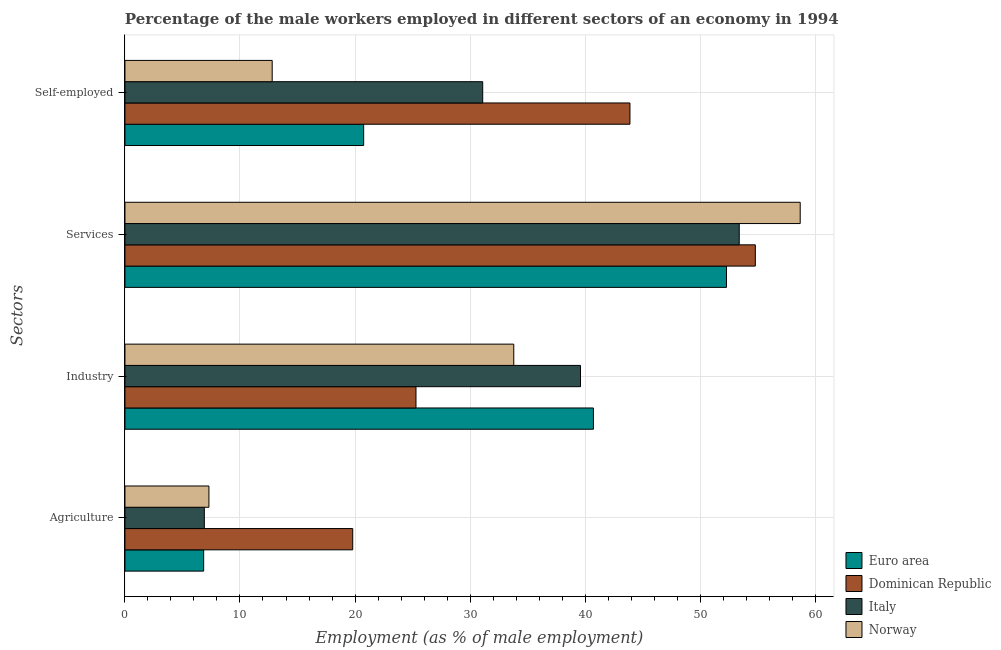How many different coloured bars are there?
Offer a very short reply. 4. How many groups of bars are there?
Offer a very short reply. 4. How many bars are there on the 4th tick from the bottom?
Ensure brevity in your answer.  4. What is the label of the 2nd group of bars from the top?
Offer a very short reply. Services. What is the percentage of male workers in agriculture in Dominican Republic?
Give a very brief answer. 19.8. Across all countries, what is the maximum percentage of male workers in services?
Ensure brevity in your answer.  58.7. Across all countries, what is the minimum percentage of self employed male workers?
Make the answer very short. 12.8. In which country was the percentage of male workers in agriculture maximum?
Keep it short and to the point. Dominican Republic. What is the total percentage of self employed male workers in the graph?
Provide a succinct answer. 108.55. What is the difference between the percentage of male workers in services in Italy and that in Dominican Republic?
Make the answer very short. -1.4. What is the difference between the percentage of self employed male workers in Norway and the percentage of male workers in industry in Italy?
Provide a short and direct response. -26.8. What is the average percentage of self employed male workers per country?
Offer a terse response. 27.14. What is the difference between the percentage of self employed male workers and percentage of male workers in services in Norway?
Offer a terse response. -45.9. What is the ratio of the percentage of male workers in agriculture in Norway to that in Italy?
Ensure brevity in your answer.  1.06. What is the difference between the highest and the second highest percentage of male workers in agriculture?
Ensure brevity in your answer.  12.5. What is the difference between the highest and the lowest percentage of male workers in industry?
Keep it short and to the point. 15.42. What does the 2nd bar from the bottom in Self-employed represents?
Offer a very short reply. Dominican Republic. Is it the case that in every country, the sum of the percentage of male workers in agriculture and percentage of male workers in industry is greater than the percentage of male workers in services?
Offer a very short reply. No. How many countries are there in the graph?
Offer a very short reply. 4. What is the difference between two consecutive major ticks on the X-axis?
Offer a very short reply. 10. Does the graph contain grids?
Ensure brevity in your answer.  Yes. What is the title of the graph?
Keep it short and to the point. Percentage of the male workers employed in different sectors of an economy in 1994. Does "Cambodia" appear as one of the legend labels in the graph?
Provide a short and direct response. No. What is the label or title of the X-axis?
Keep it short and to the point. Employment (as % of male employment). What is the label or title of the Y-axis?
Your response must be concise. Sectors. What is the Employment (as % of male employment) in Euro area in Agriculture?
Your response must be concise. 6.84. What is the Employment (as % of male employment) of Dominican Republic in Agriculture?
Make the answer very short. 19.8. What is the Employment (as % of male employment) in Italy in Agriculture?
Your response must be concise. 6.9. What is the Employment (as % of male employment) in Norway in Agriculture?
Give a very brief answer. 7.3. What is the Employment (as % of male employment) of Euro area in Industry?
Give a very brief answer. 40.72. What is the Employment (as % of male employment) in Dominican Republic in Industry?
Provide a succinct answer. 25.3. What is the Employment (as % of male employment) of Italy in Industry?
Give a very brief answer. 39.6. What is the Employment (as % of male employment) in Norway in Industry?
Your answer should be very brief. 33.8. What is the Employment (as % of male employment) in Euro area in Services?
Keep it short and to the point. 52.29. What is the Employment (as % of male employment) in Dominican Republic in Services?
Your answer should be very brief. 54.8. What is the Employment (as % of male employment) of Italy in Services?
Your answer should be very brief. 53.4. What is the Employment (as % of male employment) of Norway in Services?
Keep it short and to the point. 58.7. What is the Employment (as % of male employment) in Euro area in Self-employed?
Offer a terse response. 20.75. What is the Employment (as % of male employment) of Dominican Republic in Self-employed?
Keep it short and to the point. 43.9. What is the Employment (as % of male employment) of Italy in Self-employed?
Offer a very short reply. 31.1. What is the Employment (as % of male employment) of Norway in Self-employed?
Provide a succinct answer. 12.8. Across all Sectors, what is the maximum Employment (as % of male employment) of Euro area?
Offer a very short reply. 52.29. Across all Sectors, what is the maximum Employment (as % of male employment) in Dominican Republic?
Offer a terse response. 54.8. Across all Sectors, what is the maximum Employment (as % of male employment) of Italy?
Offer a terse response. 53.4. Across all Sectors, what is the maximum Employment (as % of male employment) in Norway?
Your response must be concise. 58.7. Across all Sectors, what is the minimum Employment (as % of male employment) of Euro area?
Make the answer very short. 6.84. Across all Sectors, what is the minimum Employment (as % of male employment) of Dominican Republic?
Your response must be concise. 19.8. Across all Sectors, what is the minimum Employment (as % of male employment) in Italy?
Ensure brevity in your answer.  6.9. Across all Sectors, what is the minimum Employment (as % of male employment) of Norway?
Make the answer very short. 7.3. What is the total Employment (as % of male employment) in Euro area in the graph?
Offer a terse response. 120.61. What is the total Employment (as % of male employment) of Dominican Republic in the graph?
Your response must be concise. 143.8. What is the total Employment (as % of male employment) in Italy in the graph?
Your response must be concise. 131. What is the total Employment (as % of male employment) in Norway in the graph?
Your answer should be compact. 112.6. What is the difference between the Employment (as % of male employment) of Euro area in Agriculture and that in Industry?
Offer a terse response. -33.88. What is the difference between the Employment (as % of male employment) of Italy in Agriculture and that in Industry?
Keep it short and to the point. -32.7. What is the difference between the Employment (as % of male employment) of Norway in Agriculture and that in Industry?
Offer a terse response. -26.5. What is the difference between the Employment (as % of male employment) of Euro area in Agriculture and that in Services?
Provide a succinct answer. -45.45. What is the difference between the Employment (as % of male employment) in Dominican Republic in Agriculture and that in Services?
Provide a short and direct response. -35. What is the difference between the Employment (as % of male employment) in Italy in Agriculture and that in Services?
Your answer should be compact. -46.5. What is the difference between the Employment (as % of male employment) of Norway in Agriculture and that in Services?
Offer a terse response. -51.4. What is the difference between the Employment (as % of male employment) of Euro area in Agriculture and that in Self-employed?
Make the answer very short. -13.91. What is the difference between the Employment (as % of male employment) in Dominican Republic in Agriculture and that in Self-employed?
Keep it short and to the point. -24.1. What is the difference between the Employment (as % of male employment) in Italy in Agriculture and that in Self-employed?
Ensure brevity in your answer.  -24.2. What is the difference between the Employment (as % of male employment) of Euro area in Industry and that in Services?
Ensure brevity in your answer.  -11.57. What is the difference between the Employment (as % of male employment) in Dominican Republic in Industry and that in Services?
Provide a short and direct response. -29.5. What is the difference between the Employment (as % of male employment) in Italy in Industry and that in Services?
Offer a terse response. -13.8. What is the difference between the Employment (as % of male employment) in Norway in Industry and that in Services?
Your response must be concise. -24.9. What is the difference between the Employment (as % of male employment) in Euro area in Industry and that in Self-employed?
Your answer should be compact. 19.97. What is the difference between the Employment (as % of male employment) of Dominican Republic in Industry and that in Self-employed?
Give a very brief answer. -18.6. What is the difference between the Employment (as % of male employment) in Euro area in Services and that in Self-employed?
Your answer should be very brief. 31.54. What is the difference between the Employment (as % of male employment) in Dominican Republic in Services and that in Self-employed?
Provide a short and direct response. 10.9. What is the difference between the Employment (as % of male employment) of Italy in Services and that in Self-employed?
Make the answer very short. 22.3. What is the difference between the Employment (as % of male employment) in Norway in Services and that in Self-employed?
Your answer should be very brief. 45.9. What is the difference between the Employment (as % of male employment) in Euro area in Agriculture and the Employment (as % of male employment) in Dominican Republic in Industry?
Your answer should be compact. -18.46. What is the difference between the Employment (as % of male employment) of Euro area in Agriculture and the Employment (as % of male employment) of Italy in Industry?
Your answer should be very brief. -32.76. What is the difference between the Employment (as % of male employment) in Euro area in Agriculture and the Employment (as % of male employment) in Norway in Industry?
Your answer should be compact. -26.96. What is the difference between the Employment (as % of male employment) in Dominican Republic in Agriculture and the Employment (as % of male employment) in Italy in Industry?
Your answer should be very brief. -19.8. What is the difference between the Employment (as % of male employment) of Italy in Agriculture and the Employment (as % of male employment) of Norway in Industry?
Your answer should be compact. -26.9. What is the difference between the Employment (as % of male employment) in Euro area in Agriculture and the Employment (as % of male employment) in Dominican Republic in Services?
Your response must be concise. -47.96. What is the difference between the Employment (as % of male employment) in Euro area in Agriculture and the Employment (as % of male employment) in Italy in Services?
Offer a terse response. -46.56. What is the difference between the Employment (as % of male employment) of Euro area in Agriculture and the Employment (as % of male employment) of Norway in Services?
Give a very brief answer. -51.86. What is the difference between the Employment (as % of male employment) of Dominican Republic in Agriculture and the Employment (as % of male employment) of Italy in Services?
Your answer should be compact. -33.6. What is the difference between the Employment (as % of male employment) of Dominican Republic in Agriculture and the Employment (as % of male employment) of Norway in Services?
Provide a short and direct response. -38.9. What is the difference between the Employment (as % of male employment) in Italy in Agriculture and the Employment (as % of male employment) in Norway in Services?
Keep it short and to the point. -51.8. What is the difference between the Employment (as % of male employment) in Euro area in Agriculture and the Employment (as % of male employment) in Dominican Republic in Self-employed?
Provide a succinct answer. -37.06. What is the difference between the Employment (as % of male employment) in Euro area in Agriculture and the Employment (as % of male employment) in Italy in Self-employed?
Your answer should be very brief. -24.26. What is the difference between the Employment (as % of male employment) of Euro area in Agriculture and the Employment (as % of male employment) of Norway in Self-employed?
Your answer should be compact. -5.96. What is the difference between the Employment (as % of male employment) of Italy in Agriculture and the Employment (as % of male employment) of Norway in Self-employed?
Your answer should be compact. -5.9. What is the difference between the Employment (as % of male employment) in Euro area in Industry and the Employment (as % of male employment) in Dominican Republic in Services?
Ensure brevity in your answer.  -14.08. What is the difference between the Employment (as % of male employment) of Euro area in Industry and the Employment (as % of male employment) of Italy in Services?
Keep it short and to the point. -12.68. What is the difference between the Employment (as % of male employment) in Euro area in Industry and the Employment (as % of male employment) in Norway in Services?
Provide a short and direct response. -17.98. What is the difference between the Employment (as % of male employment) in Dominican Republic in Industry and the Employment (as % of male employment) in Italy in Services?
Your answer should be compact. -28.1. What is the difference between the Employment (as % of male employment) of Dominican Republic in Industry and the Employment (as % of male employment) of Norway in Services?
Your response must be concise. -33.4. What is the difference between the Employment (as % of male employment) in Italy in Industry and the Employment (as % of male employment) in Norway in Services?
Your answer should be very brief. -19.1. What is the difference between the Employment (as % of male employment) in Euro area in Industry and the Employment (as % of male employment) in Dominican Republic in Self-employed?
Provide a short and direct response. -3.18. What is the difference between the Employment (as % of male employment) of Euro area in Industry and the Employment (as % of male employment) of Italy in Self-employed?
Ensure brevity in your answer.  9.62. What is the difference between the Employment (as % of male employment) of Euro area in Industry and the Employment (as % of male employment) of Norway in Self-employed?
Your answer should be compact. 27.92. What is the difference between the Employment (as % of male employment) in Dominican Republic in Industry and the Employment (as % of male employment) in Italy in Self-employed?
Keep it short and to the point. -5.8. What is the difference between the Employment (as % of male employment) of Italy in Industry and the Employment (as % of male employment) of Norway in Self-employed?
Your answer should be compact. 26.8. What is the difference between the Employment (as % of male employment) in Euro area in Services and the Employment (as % of male employment) in Dominican Republic in Self-employed?
Your answer should be very brief. 8.39. What is the difference between the Employment (as % of male employment) of Euro area in Services and the Employment (as % of male employment) of Italy in Self-employed?
Provide a short and direct response. 21.19. What is the difference between the Employment (as % of male employment) in Euro area in Services and the Employment (as % of male employment) in Norway in Self-employed?
Your answer should be compact. 39.49. What is the difference between the Employment (as % of male employment) in Dominican Republic in Services and the Employment (as % of male employment) in Italy in Self-employed?
Offer a terse response. 23.7. What is the difference between the Employment (as % of male employment) in Italy in Services and the Employment (as % of male employment) in Norway in Self-employed?
Your response must be concise. 40.6. What is the average Employment (as % of male employment) of Euro area per Sectors?
Give a very brief answer. 30.15. What is the average Employment (as % of male employment) of Dominican Republic per Sectors?
Make the answer very short. 35.95. What is the average Employment (as % of male employment) in Italy per Sectors?
Provide a succinct answer. 32.75. What is the average Employment (as % of male employment) of Norway per Sectors?
Give a very brief answer. 28.15. What is the difference between the Employment (as % of male employment) in Euro area and Employment (as % of male employment) in Dominican Republic in Agriculture?
Keep it short and to the point. -12.96. What is the difference between the Employment (as % of male employment) of Euro area and Employment (as % of male employment) of Italy in Agriculture?
Ensure brevity in your answer.  -0.06. What is the difference between the Employment (as % of male employment) of Euro area and Employment (as % of male employment) of Norway in Agriculture?
Provide a succinct answer. -0.46. What is the difference between the Employment (as % of male employment) in Dominican Republic and Employment (as % of male employment) in Italy in Agriculture?
Offer a very short reply. 12.9. What is the difference between the Employment (as % of male employment) in Italy and Employment (as % of male employment) in Norway in Agriculture?
Your answer should be very brief. -0.4. What is the difference between the Employment (as % of male employment) in Euro area and Employment (as % of male employment) in Dominican Republic in Industry?
Ensure brevity in your answer.  15.42. What is the difference between the Employment (as % of male employment) in Euro area and Employment (as % of male employment) in Italy in Industry?
Offer a terse response. 1.12. What is the difference between the Employment (as % of male employment) of Euro area and Employment (as % of male employment) of Norway in Industry?
Provide a succinct answer. 6.92. What is the difference between the Employment (as % of male employment) in Dominican Republic and Employment (as % of male employment) in Italy in Industry?
Offer a terse response. -14.3. What is the difference between the Employment (as % of male employment) in Italy and Employment (as % of male employment) in Norway in Industry?
Offer a terse response. 5.8. What is the difference between the Employment (as % of male employment) in Euro area and Employment (as % of male employment) in Dominican Republic in Services?
Provide a short and direct response. -2.51. What is the difference between the Employment (as % of male employment) of Euro area and Employment (as % of male employment) of Italy in Services?
Offer a very short reply. -1.11. What is the difference between the Employment (as % of male employment) in Euro area and Employment (as % of male employment) in Norway in Services?
Your answer should be compact. -6.41. What is the difference between the Employment (as % of male employment) in Dominican Republic and Employment (as % of male employment) in Italy in Services?
Keep it short and to the point. 1.4. What is the difference between the Employment (as % of male employment) in Dominican Republic and Employment (as % of male employment) in Norway in Services?
Your answer should be very brief. -3.9. What is the difference between the Employment (as % of male employment) in Euro area and Employment (as % of male employment) in Dominican Republic in Self-employed?
Offer a terse response. -23.15. What is the difference between the Employment (as % of male employment) of Euro area and Employment (as % of male employment) of Italy in Self-employed?
Your response must be concise. -10.35. What is the difference between the Employment (as % of male employment) in Euro area and Employment (as % of male employment) in Norway in Self-employed?
Your response must be concise. 7.95. What is the difference between the Employment (as % of male employment) in Dominican Republic and Employment (as % of male employment) in Italy in Self-employed?
Give a very brief answer. 12.8. What is the difference between the Employment (as % of male employment) of Dominican Republic and Employment (as % of male employment) of Norway in Self-employed?
Your answer should be very brief. 31.1. What is the ratio of the Employment (as % of male employment) in Euro area in Agriculture to that in Industry?
Ensure brevity in your answer.  0.17. What is the ratio of the Employment (as % of male employment) of Dominican Republic in Agriculture to that in Industry?
Offer a terse response. 0.78. What is the ratio of the Employment (as % of male employment) of Italy in Agriculture to that in Industry?
Offer a terse response. 0.17. What is the ratio of the Employment (as % of male employment) in Norway in Agriculture to that in Industry?
Make the answer very short. 0.22. What is the ratio of the Employment (as % of male employment) in Euro area in Agriculture to that in Services?
Offer a very short reply. 0.13. What is the ratio of the Employment (as % of male employment) in Dominican Republic in Agriculture to that in Services?
Your answer should be compact. 0.36. What is the ratio of the Employment (as % of male employment) in Italy in Agriculture to that in Services?
Your answer should be compact. 0.13. What is the ratio of the Employment (as % of male employment) in Norway in Agriculture to that in Services?
Give a very brief answer. 0.12. What is the ratio of the Employment (as % of male employment) of Euro area in Agriculture to that in Self-employed?
Offer a very short reply. 0.33. What is the ratio of the Employment (as % of male employment) in Dominican Republic in Agriculture to that in Self-employed?
Ensure brevity in your answer.  0.45. What is the ratio of the Employment (as % of male employment) in Italy in Agriculture to that in Self-employed?
Ensure brevity in your answer.  0.22. What is the ratio of the Employment (as % of male employment) in Norway in Agriculture to that in Self-employed?
Your answer should be compact. 0.57. What is the ratio of the Employment (as % of male employment) in Euro area in Industry to that in Services?
Keep it short and to the point. 0.78. What is the ratio of the Employment (as % of male employment) in Dominican Republic in Industry to that in Services?
Keep it short and to the point. 0.46. What is the ratio of the Employment (as % of male employment) in Italy in Industry to that in Services?
Offer a terse response. 0.74. What is the ratio of the Employment (as % of male employment) of Norway in Industry to that in Services?
Keep it short and to the point. 0.58. What is the ratio of the Employment (as % of male employment) in Euro area in Industry to that in Self-employed?
Keep it short and to the point. 1.96. What is the ratio of the Employment (as % of male employment) in Dominican Republic in Industry to that in Self-employed?
Make the answer very short. 0.58. What is the ratio of the Employment (as % of male employment) of Italy in Industry to that in Self-employed?
Provide a succinct answer. 1.27. What is the ratio of the Employment (as % of male employment) of Norway in Industry to that in Self-employed?
Offer a terse response. 2.64. What is the ratio of the Employment (as % of male employment) of Euro area in Services to that in Self-employed?
Offer a terse response. 2.52. What is the ratio of the Employment (as % of male employment) in Dominican Republic in Services to that in Self-employed?
Make the answer very short. 1.25. What is the ratio of the Employment (as % of male employment) in Italy in Services to that in Self-employed?
Your response must be concise. 1.72. What is the ratio of the Employment (as % of male employment) in Norway in Services to that in Self-employed?
Your response must be concise. 4.59. What is the difference between the highest and the second highest Employment (as % of male employment) in Euro area?
Provide a short and direct response. 11.57. What is the difference between the highest and the second highest Employment (as % of male employment) in Dominican Republic?
Provide a succinct answer. 10.9. What is the difference between the highest and the second highest Employment (as % of male employment) in Norway?
Your answer should be very brief. 24.9. What is the difference between the highest and the lowest Employment (as % of male employment) of Euro area?
Give a very brief answer. 45.45. What is the difference between the highest and the lowest Employment (as % of male employment) in Dominican Republic?
Your answer should be very brief. 35. What is the difference between the highest and the lowest Employment (as % of male employment) of Italy?
Offer a very short reply. 46.5. What is the difference between the highest and the lowest Employment (as % of male employment) of Norway?
Offer a very short reply. 51.4. 